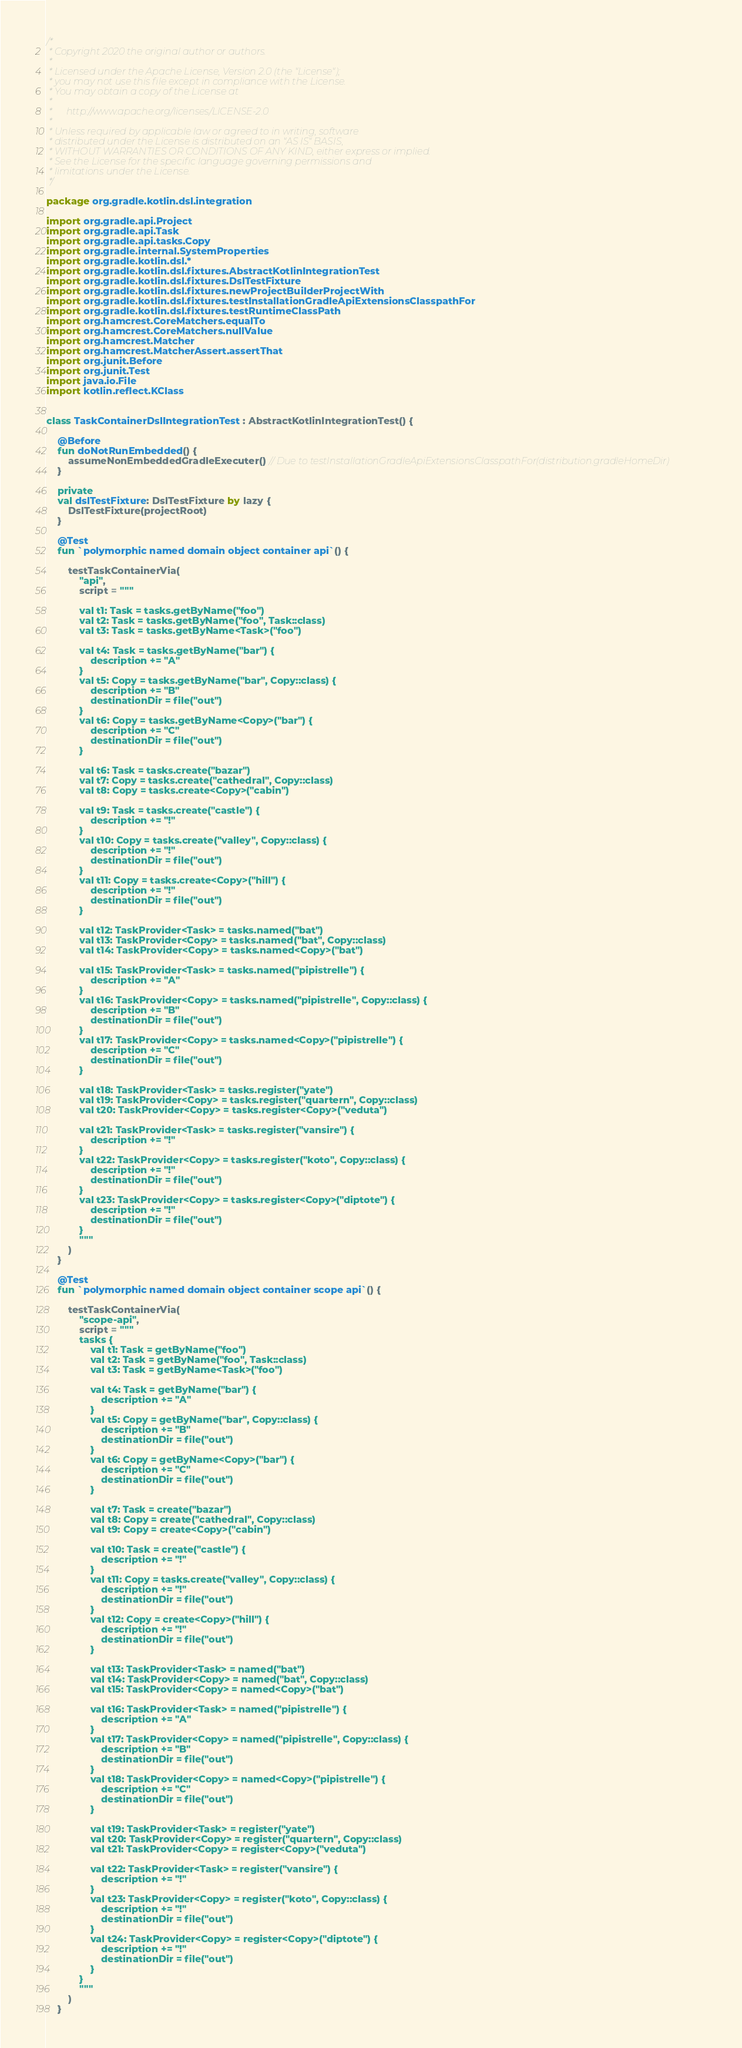Convert code to text. <code><loc_0><loc_0><loc_500><loc_500><_Kotlin_>/*
 * Copyright 2020 the original author or authors.
 *
 * Licensed under the Apache License, Version 2.0 (the "License");
 * you may not use this file except in compliance with the License.
 * You may obtain a copy of the License at
 *
 *      http://www.apache.org/licenses/LICENSE-2.0
 *
 * Unless required by applicable law or agreed to in writing, software
 * distributed under the License is distributed on an "AS IS" BASIS,
 * WITHOUT WARRANTIES OR CONDITIONS OF ANY KIND, either express or implied.
 * See the License for the specific language governing permissions and
 * limitations under the License.
 */

package org.gradle.kotlin.dsl.integration

import org.gradle.api.Project
import org.gradle.api.Task
import org.gradle.api.tasks.Copy
import org.gradle.internal.SystemProperties
import org.gradle.kotlin.dsl.*
import org.gradle.kotlin.dsl.fixtures.AbstractKotlinIntegrationTest
import org.gradle.kotlin.dsl.fixtures.DslTestFixture
import org.gradle.kotlin.dsl.fixtures.newProjectBuilderProjectWith
import org.gradle.kotlin.dsl.fixtures.testInstallationGradleApiExtensionsClasspathFor
import org.gradle.kotlin.dsl.fixtures.testRuntimeClassPath
import org.hamcrest.CoreMatchers.equalTo
import org.hamcrest.CoreMatchers.nullValue
import org.hamcrest.Matcher
import org.hamcrest.MatcherAssert.assertThat
import org.junit.Before
import org.junit.Test
import java.io.File
import kotlin.reflect.KClass


class TaskContainerDslIntegrationTest : AbstractKotlinIntegrationTest() {

    @Before
    fun doNotRunEmbedded() {
        assumeNonEmbeddedGradleExecuter() // Due to testInstallationGradleApiExtensionsClasspathFor(distribution.gradleHomeDir)
    }

    private
    val dslTestFixture: DslTestFixture by lazy {
        DslTestFixture(projectRoot)
    }

    @Test
    fun `polymorphic named domain object container api`() {

        testTaskContainerVia(
            "api",
            script = """

            val t1: Task = tasks.getByName("foo")
            val t2: Task = tasks.getByName("foo", Task::class)
            val t3: Task = tasks.getByName<Task>("foo")

            val t4: Task = tasks.getByName("bar") {
                description += "A"
            }
            val t5: Copy = tasks.getByName("bar", Copy::class) {
                description += "B"
                destinationDir = file("out")
            }
            val t6: Copy = tasks.getByName<Copy>("bar") {
                description += "C"
                destinationDir = file("out")
            }

            val t6: Task = tasks.create("bazar")
            val t7: Copy = tasks.create("cathedral", Copy::class)
            val t8: Copy = tasks.create<Copy>("cabin")

            val t9: Task = tasks.create("castle") {
                description += "!"
            }
            val t10: Copy = tasks.create("valley", Copy::class) {
                description += "!"
                destinationDir = file("out")
            }
            val t11: Copy = tasks.create<Copy>("hill") {
                description += "!"
                destinationDir = file("out")
            }

            val t12: TaskProvider<Task> = tasks.named("bat")
            val t13: TaskProvider<Copy> = tasks.named("bat", Copy::class)
            val t14: TaskProvider<Copy> = tasks.named<Copy>("bat")

            val t15: TaskProvider<Task> = tasks.named("pipistrelle") {
                description += "A"
            }
            val t16: TaskProvider<Copy> = tasks.named("pipistrelle", Copy::class) {
                description += "B"
                destinationDir = file("out")
            }
            val t17: TaskProvider<Copy> = tasks.named<Copy>("pipistrelle") {
                description += "C"
                destinationDir = file("out")
            }

            val t18: TaskProvider<Task> = tasks.register("yate")
            val t19: TaskProvider<Copy> = tasks.register("quartern", Copy::class)
            val t20: TaskProvider<Copy> = tasks.register<Copy>("veduta")

            val t21: TaskProvider<Task> = tasks.register("vansire") {
                description += "!"
            }
            val t22: TaskProvider<Copy> = tasks.register("koto", Copy::class) {
                description += "!"
                destinationDir = file("out")
            }
            val t23: TaskProvider<Copy> = tasks.register<Copy>("diptote") {
                description += "!"
                destinationDir = file("out")
            }
            """
        )
    }

    @Test
    fun `polymorphic named domain object container scope api`() {

        testTaskContainerVia(
            "scope-api",
            script = """
            tasks {
                val t1: Task = getByName("foo")
                val t2: Task = getByName("foo", Task::class)
                val t3: Task = getByName<Task>("foo")

                val t4: Task = getByName("bar") {
                    description += "A"
                }
                val t5: Copy = getByName("bar", Copy::class) {
                    description += "B"
                    destinationDir = file("out")
                }
                val t6: Copy = getByName<Copy>("bar") {
                    description += "C"
                    destinationDir = file("out")
                }

                val t7: Task = create("bazar")
                val t8: Copy = create("cathedral", Copy::class)
                val t9: Copy = create<Copy>("cabin")

                val t10: Task = create("castle") {
                    description += "!"
                }
                val t11: Copy = tasks.create("valley", Copy::class) {
                    description += "!"
                    destinationDir = file("out")
                }
                val t12: Copy = create<Copy>("hill") {
                    description += "!"
                    destinationDir = file("out")
                }

                val t13: TaskProvider<Task> = named("bat")
                val t14: TaskProvider<Copy> = named("bat", Copy::class)
                val t15: TaskProvider<Copy> = named<Copy>("bat")

                val t16: TaskProvider<Task> = named("pipistrelle") {
                    description += "A"
                }
                val t17: TaskProvider<Copy> = named("pipistrelle", Copy::class) {
                    description += "B"
                    destinationDir = file("out")
                }
                val t18: TaskProvider<Copy> = named<Copy>("pipistrelle") {
                    description += "C"
                    destinationDir = file("out")
                }

                val t19: TaskProvider<Task> = register("yate")
                val t20: TaskProvider<Copy> = register("quartern", Copy::class)
                val t21: TaskProvider<Copy> = register<Copy>("veduta")

                val t22: TaskProvider<Task> = register("vansire") {
                    description += "!"
                }
                val t23: TaskProvider<Copy> = register("koto", Copy::class) {
                    description += "!"
                    destinationDir = file("out")
                }
                val t24: TaskProvider<Copy> = register<Copy>("diptote") {
                    description += "!"
                    destinationDir = file("out")
                }
            }
            """
        )
    }
</code> 